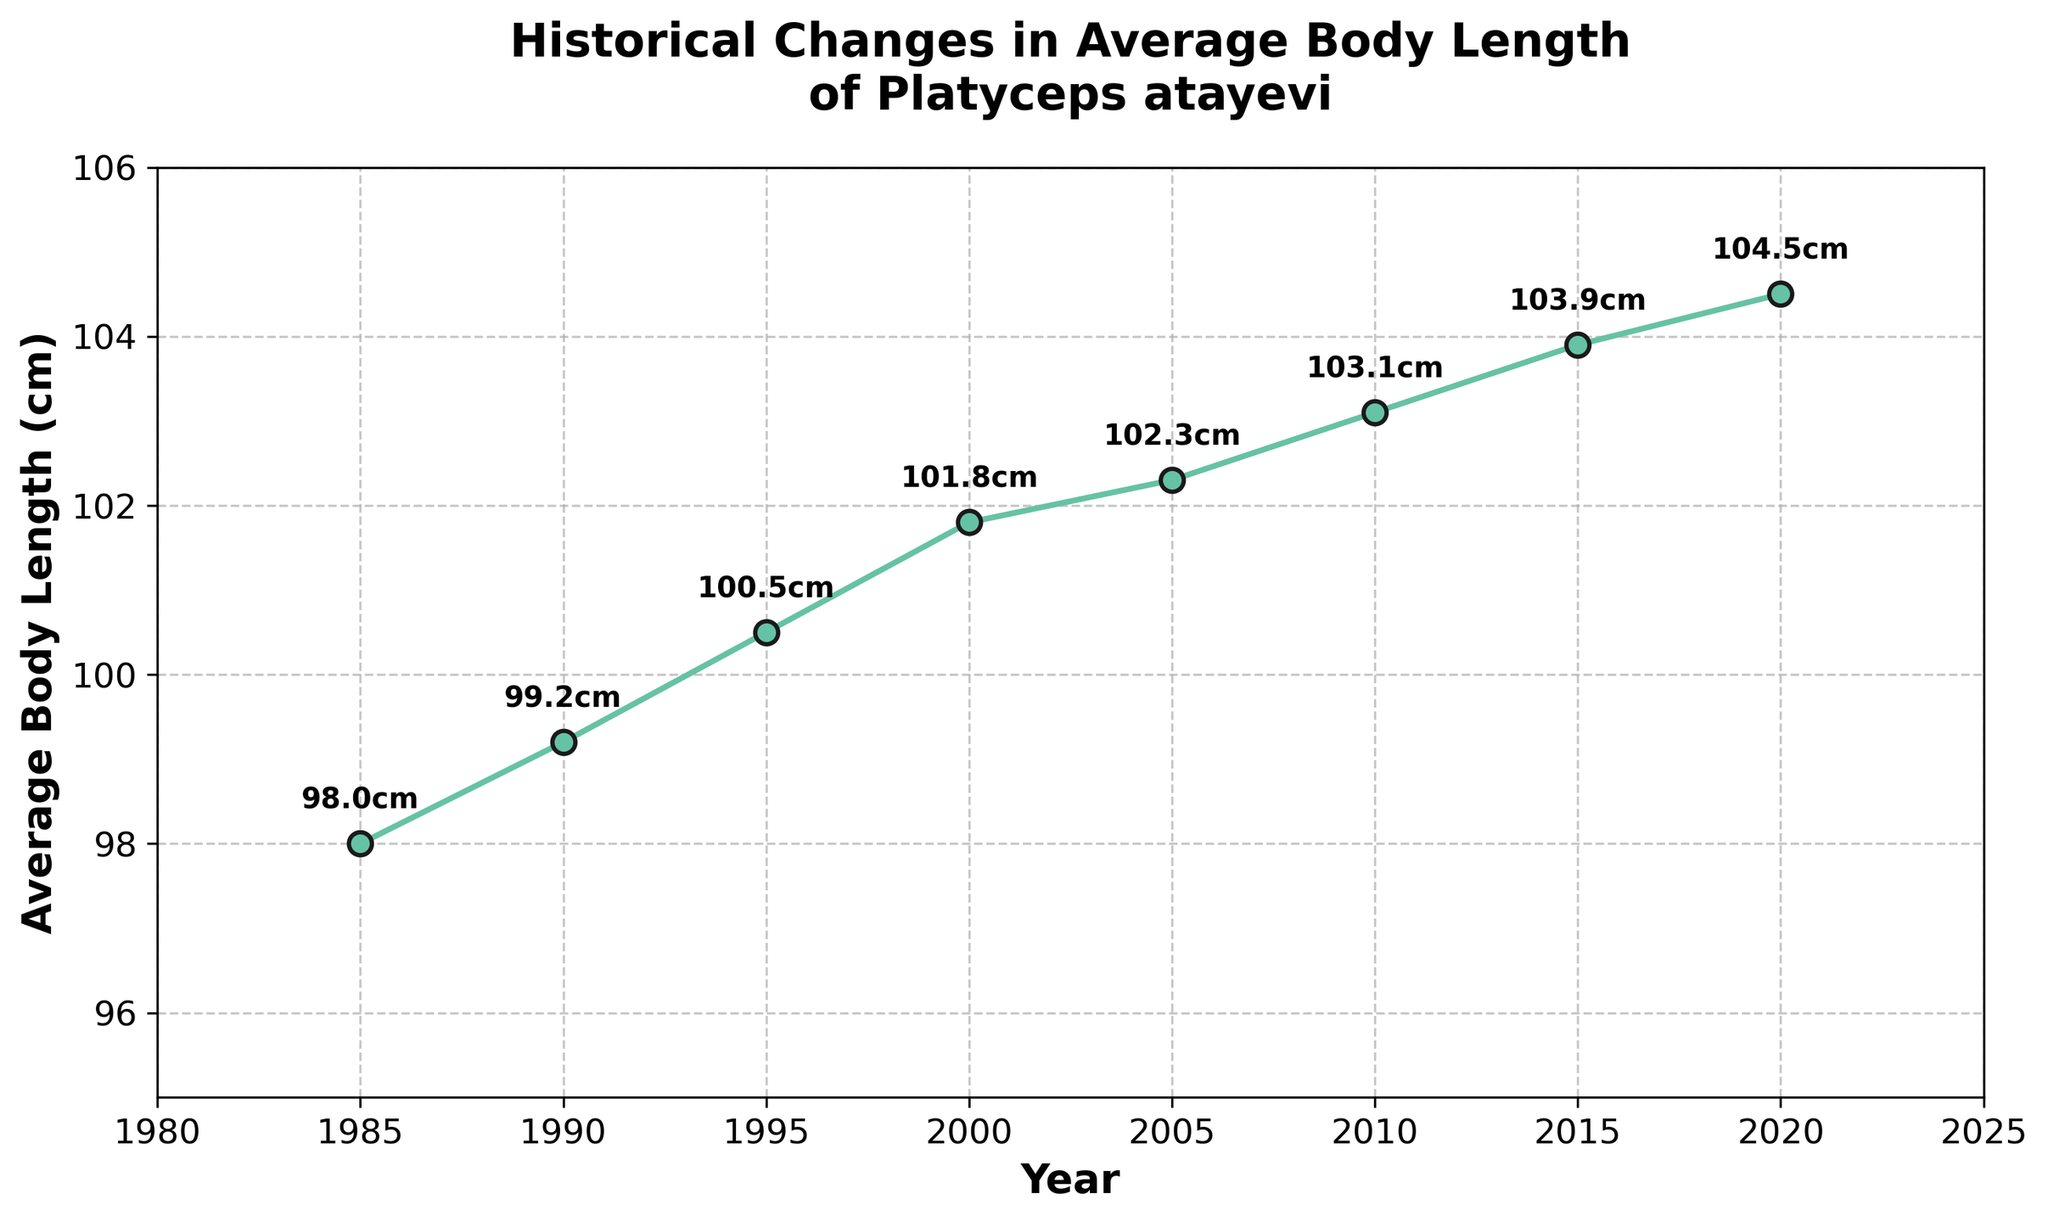What's the trend in the average body length of Platyceps atayevi from 1985 to 2020? The figure shows a line plot with data points increasing from 1985 to 2020. This indicates a general upward trend in the average body length over the years.
Answer: Upward trend What is the difference in the average body length between 1985 and 2020? The average body length in 1985 is 98 cm and in 2020 is 104.5 cm. The difference is calculated as 104.5 - 98.
Answer: 6.5 cm In which year did the average body length first exceed 100 cm? By looking at the plotted data, we can see that in 1995 the average body length first exceeded 100 cm (100.5 cm).
Answer: 1995 By how much did the average body length increase from 1995 to 2015? The average body length in 1995 was 100.5 cm and in 2015 it was 103.9 cm. The increase is calculated as 103.9 - 100.5.
Answer: 3.4 cm Which year had the smallest increase in average body length compared to the previous recorded year, and what was the increase? Comparing the differences: 
1990-1985: 99.2 - 98 = 1.2 cm; 
1995-1990: 100.5 - 99.2 = 1.3 cm; 
2000-1995: 101.8 - 100.5 = 1.3 cm; 
2005-2000: 102.3 - 101.8 = 0.5 cm; 
2010-2005: 103.1 - 102.3 = 0.8 cm; 
2015-2010: 103.9 - 103.1 = 0.8 cm; 
2020-2015: 104.5 - 103.9 = 0.6 cm. 
The smallest increase was in 2005 with a change of 0.5 cm.
Answer: 2005, 0.5 cm Was there any period where the average body length decreased? The figure shows that the average body length increased every time from one recorded year to the next. There are no periods with a decrease.
Answer: No What was the average annual increase in body length from 1985 to 2020? Over the 35-year period (2020-1985), the increase in length was 104.5 - 98 = 6.5 cm. To find the average annual increase: 6.5 cm / 35 years.
Answer: 0.1857 cm/year How does the rate of increase in the average body length from 2000 to 2010 compare with that from 2010 to 2020? From 2000 to 2010: 103.1 - 101.8 = 1.3 cm in 10 years, so 1.3 / 10 = 0.13 cm/year.
From 2010 to 2020: 104.5 - 103.1 = 1.4 cm in 10 years, so 1.4 / 10 = 0.14 cm/year. 
The rate increased slightly in the latter decade.
Answer: 0.13 cm/year (2000-2010), 0.14 cm/year (2010-2020) Describe the color and style of the data line in the plot. The line is green with circular markers connected by a solid line, and the markers have black outlines.
Answer: Green with circular markers What is the highest recorded average body length, and in which year was it recorded? The highest average body length recorded is 104.5 cm in the year 2020.
Answer: 104.5 cm, 2020 